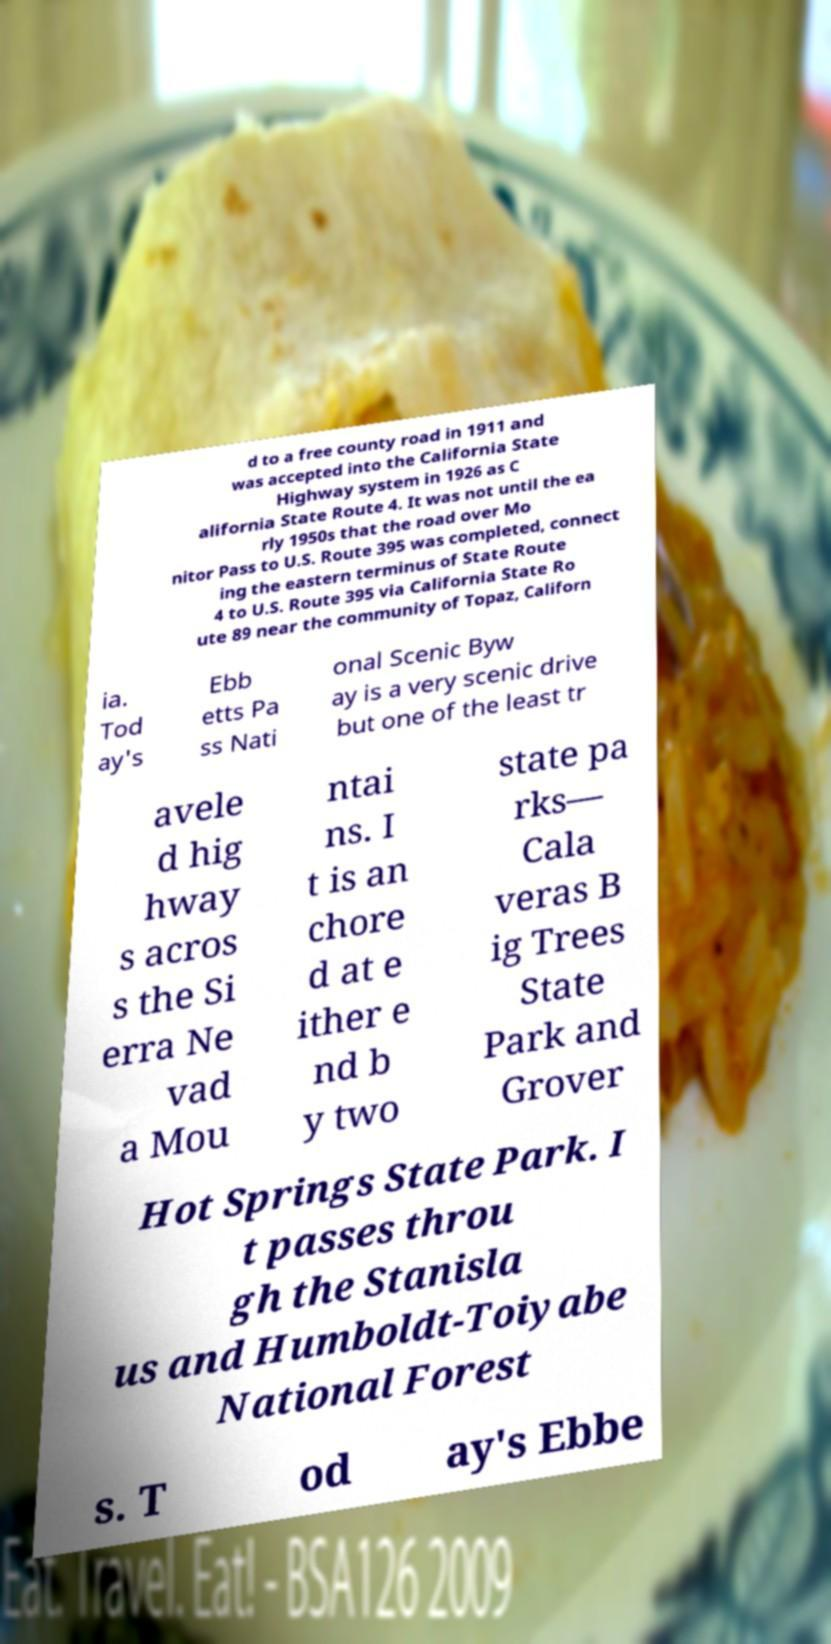Could you extract and type out the text from this image? d to a free county road in 1911 and was accepted into the California State Highway system in 1926 as C alifornia State Route 4. It was not until the ea rly 1950s that the road over Mo nitor Pass to U.S. Route 395 was completed, connect ing the eastern terminus of State Route 4 to U.S. Route 395 via California State Ro ute 89 near the community of Topaz, Californ ia. Tod ay's Ebb etts Pa ss Nati onal Scenic Byw ay is a very scenic drive but one of the least tr avele d hig hway s acros s the Si erra Ne vad a Mou ntai ns. I t is an chore d at e ither e nd b y two state pa rks— Cala veras B ig Trees State Park and Grover Hot Springs State Park. I t passes throu gh the Stanisla us and Humboldt-Toiyabe National Forest s. T od ay's Ebbe 